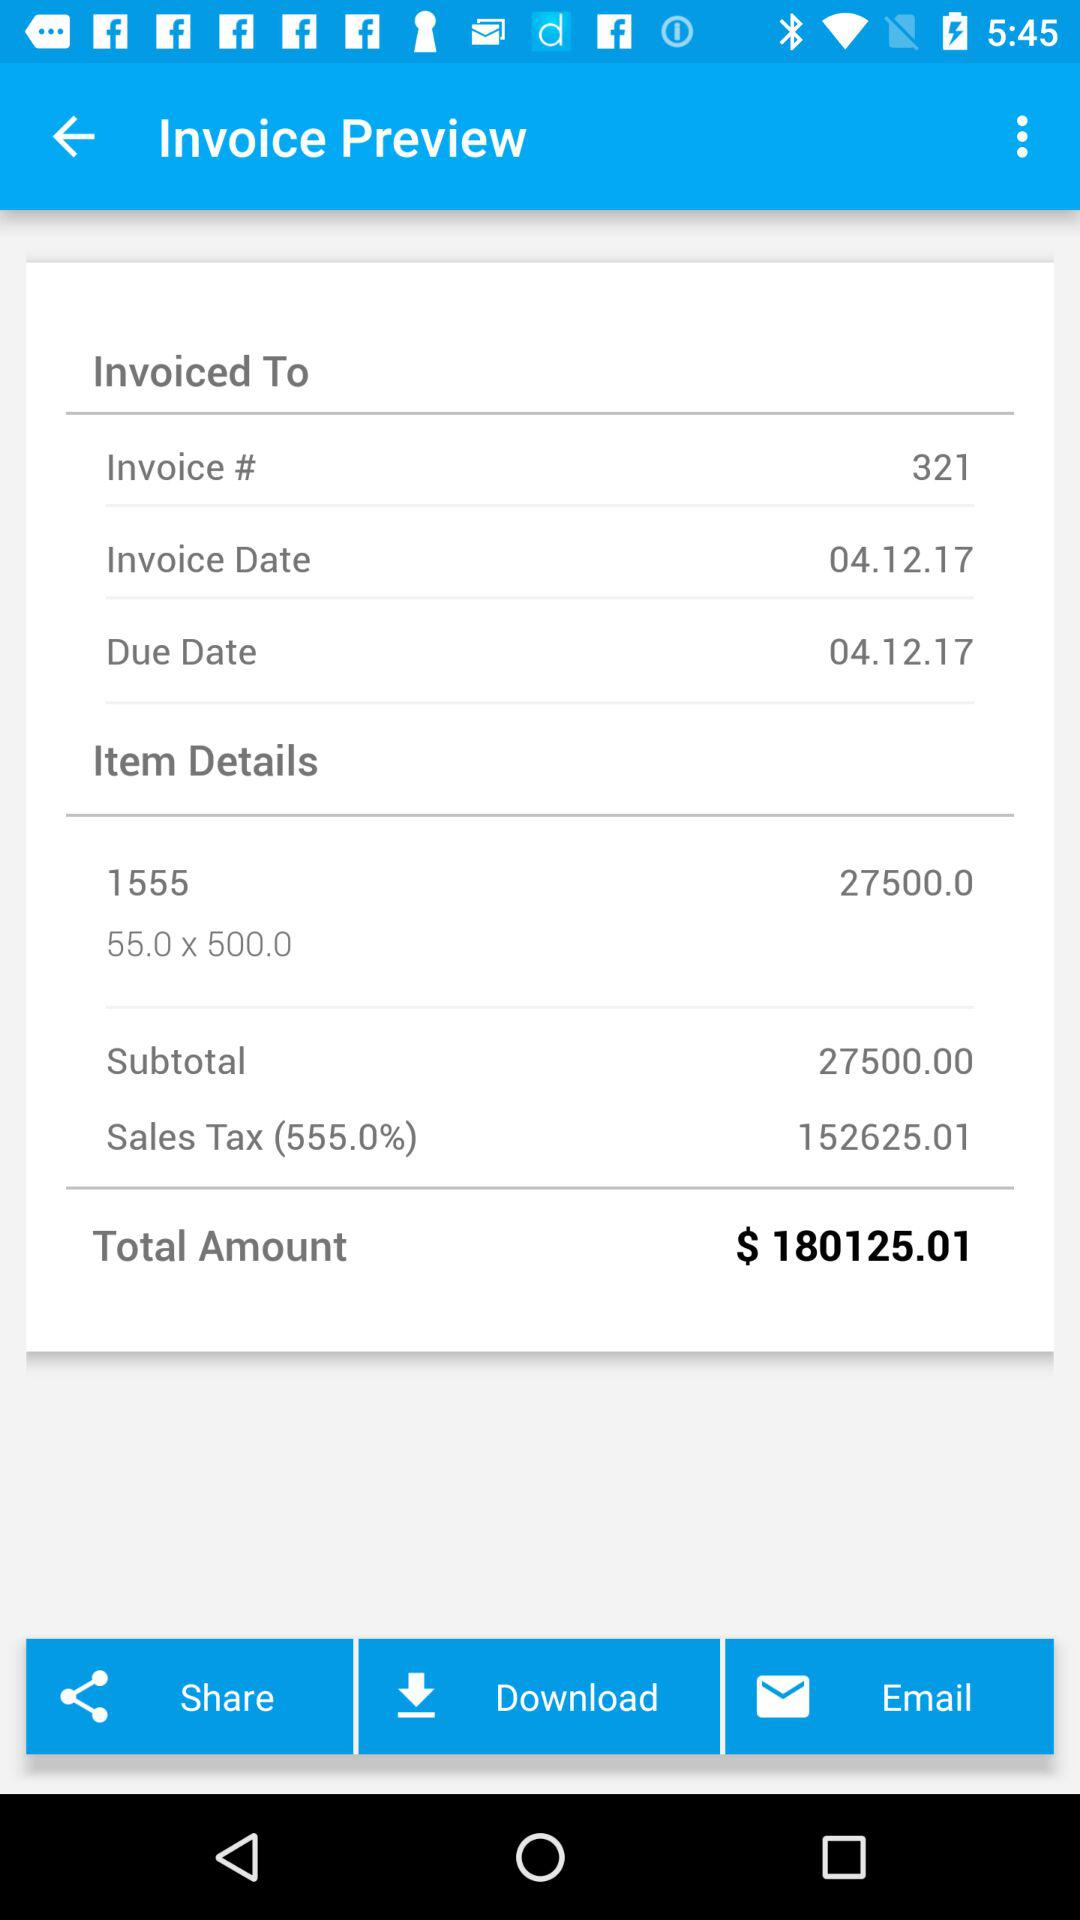What's the due date of the invoice? The due date is 04.12.17. 